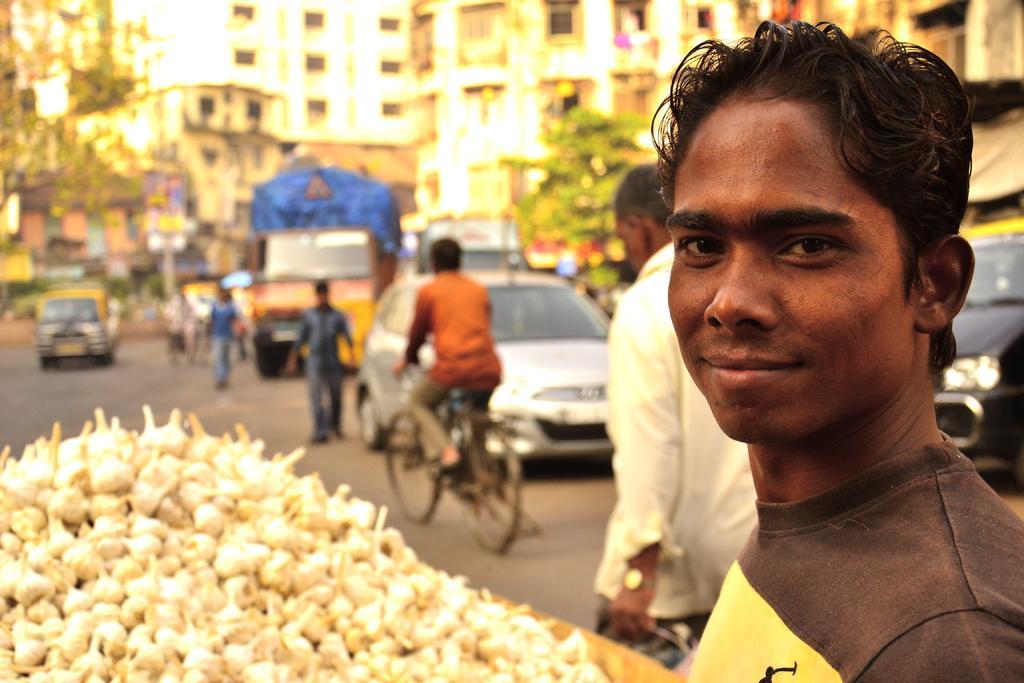How would you summarize this image in a sentence or two? In this picture, In the right side there is a boy standing, In the left side there are some white color objects, In the background there are some car and a bicycle and a man riding a bicycle and there are buildings and trees which are in green color. 